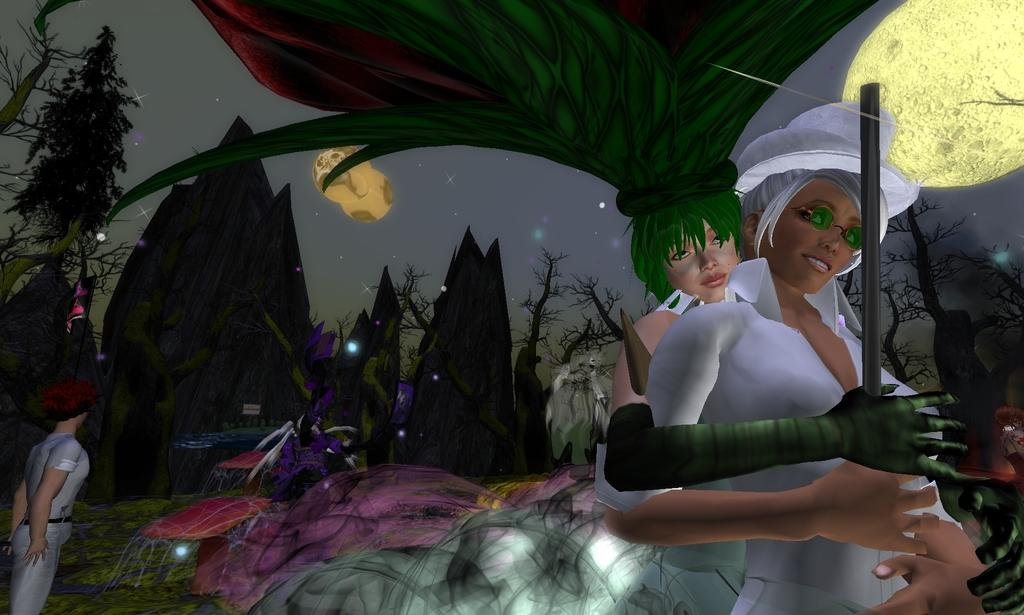What type of elements are present in the image? The image contains animated elements. Who or what can be seen in the image? There are people in the image. What type of natural elements are present in the image? There are trees in the image. What can be seen in the sky in the image? Stars are visible in the sky in the image. What type of arm is visible in the image? There is no arm present in the image. What type of quill is being used by the people in the image? There is no quill present in the image. 